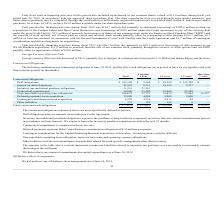According to Extreme Networks's financial document, What did Debt obligations relate to? amounts owed under our Credit Agreement.. The document states: "Debt obligations relate to amounts owed under our Credit Agreement...." Also, What does Inventory unconditional purchase obligations represent? the purchase of long lead-time component inventory that our contract manufacturers procure in accordance with our forecast. The document states: "tory unconditional purchase obligations represent the purchase of long lead-time component inventory that our contract manufacturers procure in accord..." Also, What was the total amount of interest on debt obligations? According to the financial document, 25,582 (in thousands). The relevant text states: "Interest on debt obligations 25,582 8,333 14,952 2,297 —..." Also, How many types of contractual obligations had a total that exceeded $100,000 thousand? Counting the relevant items in the document: Debt obligations, Non-cancellable operating lease obligations, I find 2 instances. The key data points involved are: Debt obligations, Non-cancellable operating lease obligations. Also, can you calculate: What was the difference in the total between Contractual commitments and Inventory unconditional purchase obligations? Based on the calculation: 94,000-51,241, the result is 42759 (in thousands). This is based on the information: "Contractual commitments 94,000 23,500 47,000 23,500 — Inventory unconditional purchase obligations 51,241 51,241 — — —..." The key data points involved are: 51,241, 94,000. Also, can you calculate: What was the difference in the total between Deferred payments for an acquisition and Contingent consideration for an acquisition? Based on the calculation: 15,000-6,298, the result is 8702 (in thousands). This is based on the information: "Contingent consideration for an acquisition 6,298 4,236 2,013 49 — Deferred payments for an acquisition 15,000 4,000 8,000 3,000 —..." The key data points involved are: 15,000, 6,298. 